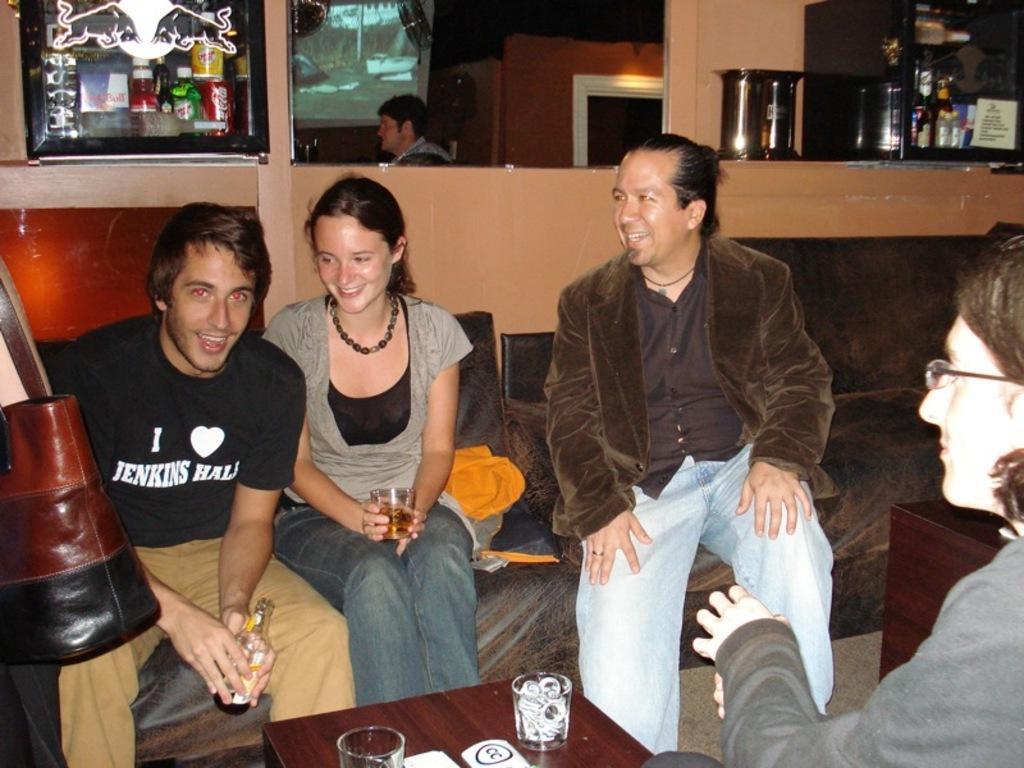In one or two sentences, can you explain what this image depicts? In this picture, we can see a group of people are sitting on a couch and a man in the black t shirt is holding a bottle. In front of the people there is a table and on the table there are glasses. Behind the people there is a wall and other objects. 